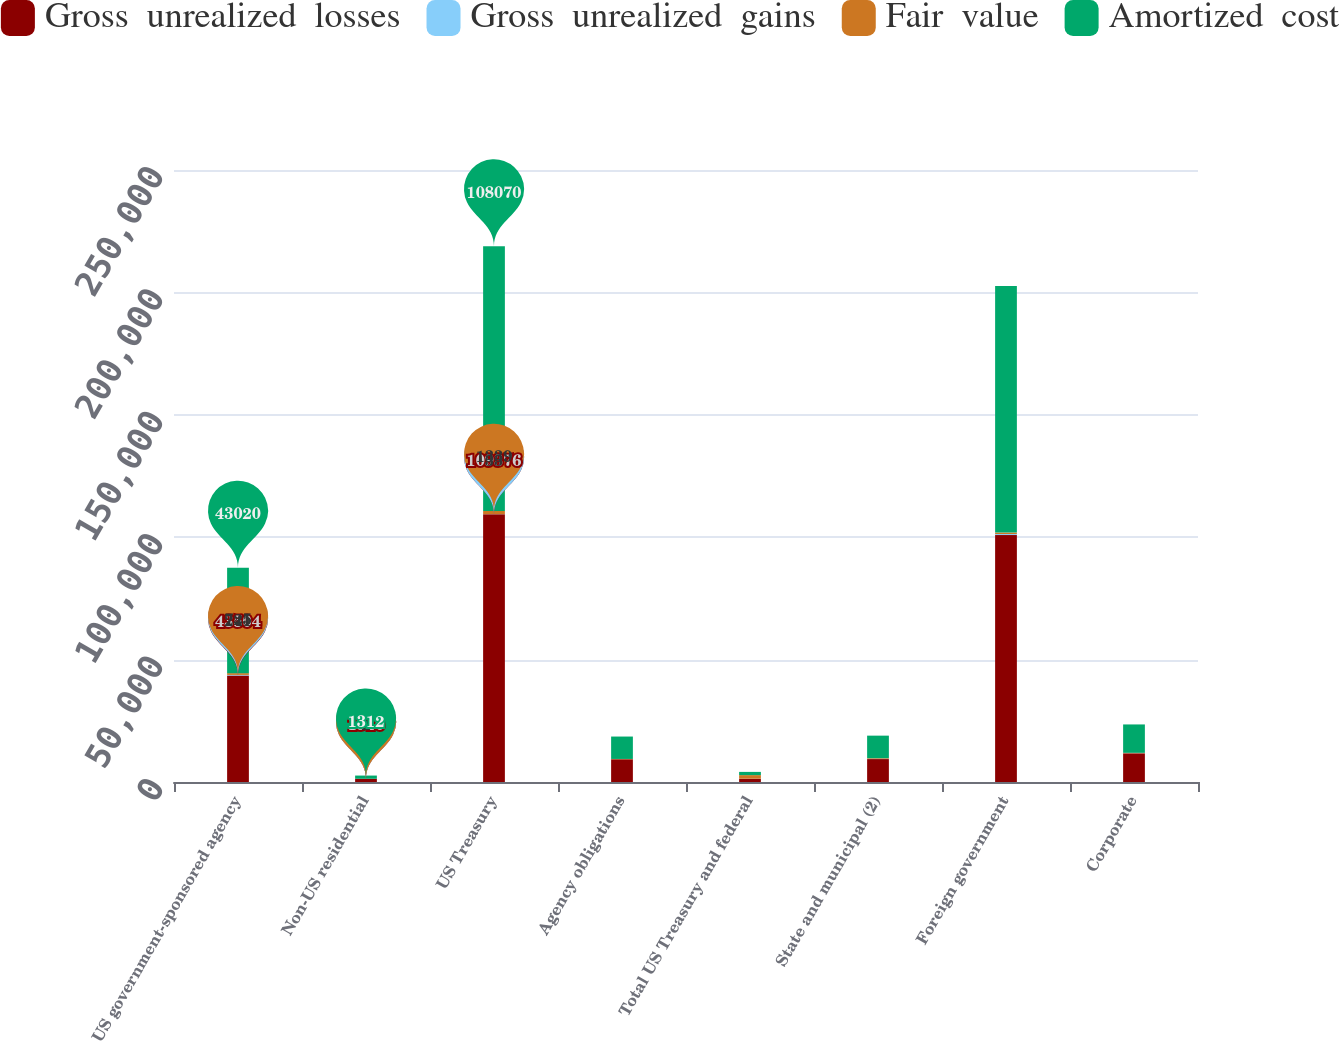Convert chart to OTSL. <chart><loc_0><loc_0><loc_500><loc_500><stacked_bar_chart><ecel><fcel>US government-sponsored agency<fcel>Non-US residential<fcel>US Treasury<fcel>Agency obligations<fcel>Total US Treasury and federal<fcel>State and municipal (2)<fcel>Foreign government<fcel>Corporate<nl><fcel>Gross  unrealized  losses<fcel>43504<fcel>1310<fcel>109376<fcel>9283<fcel>1311<fcel>9372<fcel>100872<fcel>11714<nl><fcel>Gross  unrealized  gains<fcel>241<fcel>4<fcel>33<fcel>1<fcel>34<fcel>96<fcel>415<fcel>42<nl><fcel>Fair  value<fcel>725<fcel>2<fcel>1339<fcel>132<fcel>1471<fcel>262<fcel>596<fcel>157<nl><fcel>Amortized  cost<fcel>43020<fcel>1312<fcel>108070<fcel>9152<fcel>1311<fcel>9206<fcel>100691<fcel>11599<nl></chart> 